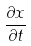<formula> <loc_0><loc_0><loc_500><loc_500>\frac { \partial x } { \partial t }</formula> 